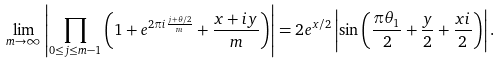Convert formula to latex. <formula><loc_0><loc_0><loc_500><loc_500>\lim _ { m \to \infty } \left | \prod _ { 0 \leq j \leq m - 1 } \left ( 1 + e ^ { 2 \pi i \frac { j + \theta / 2 } { m } } + \frac { x + i y } { m } \right ) \right | = 2 e ^ { x / 2 } \left | \sin \left ( \frac { \pi \theta _ { 1 } } { 2 } + \frac { y } { 2 } + \frac { x i } { 2 } \right ) \right | .</formula> 